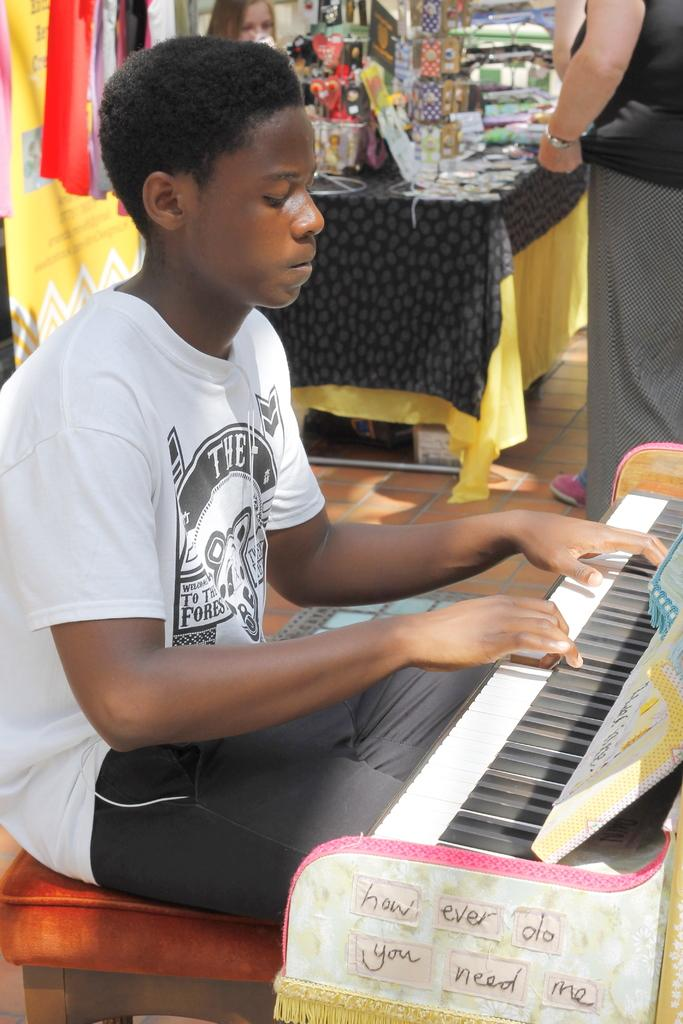What is the person in the image doing? The person is playing a musical instrument. What is the person wearing in the image? The person is wearing a white T-shirt. Who else is present in the image? There is a woman standing in the image. What can be seen in the background of the image? There are items in the background of the image. What type of spoon is being used to play the musical instrument in the image? There is no spoon present in the image, and the person is not using a spoon to play the musical instrument. 